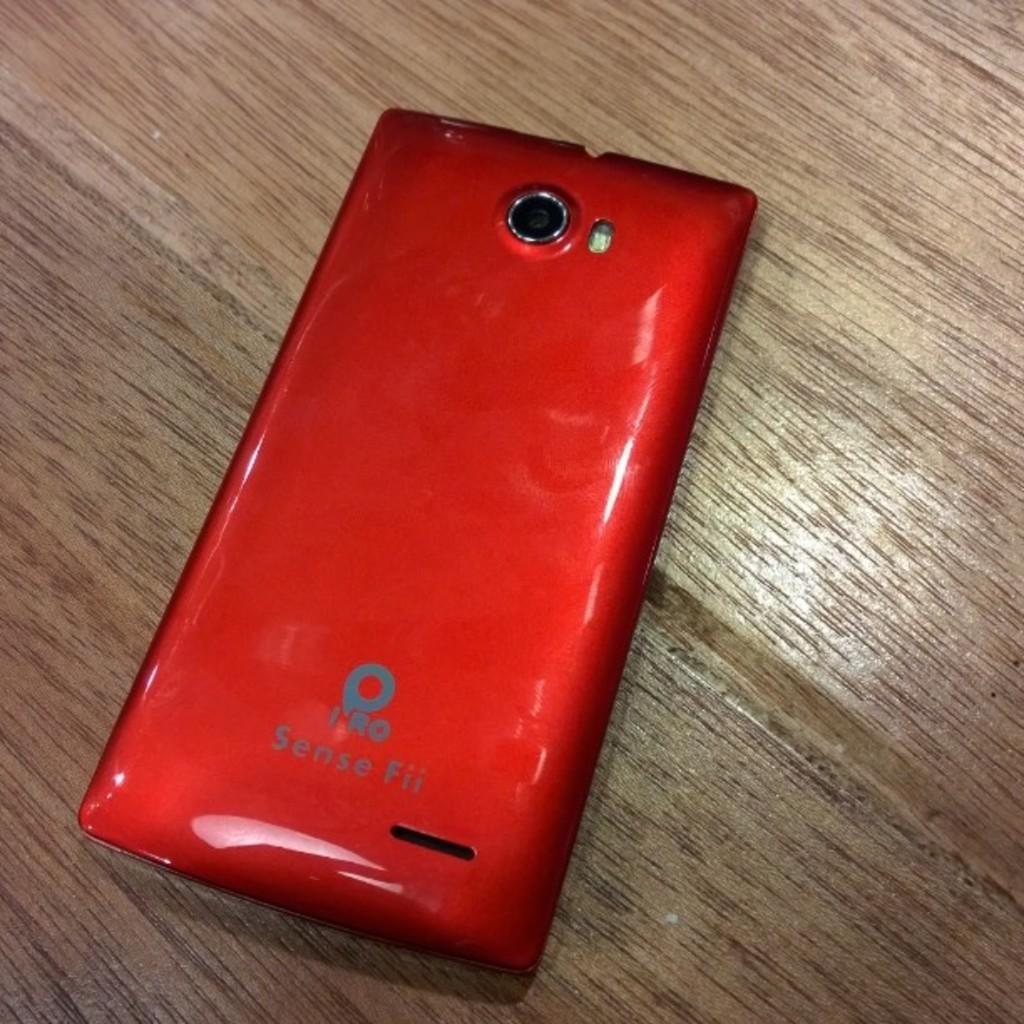<image>
Render a clear and concise summary of the photo. A red Sense Fii smart phone lies face down on a wooden surface 